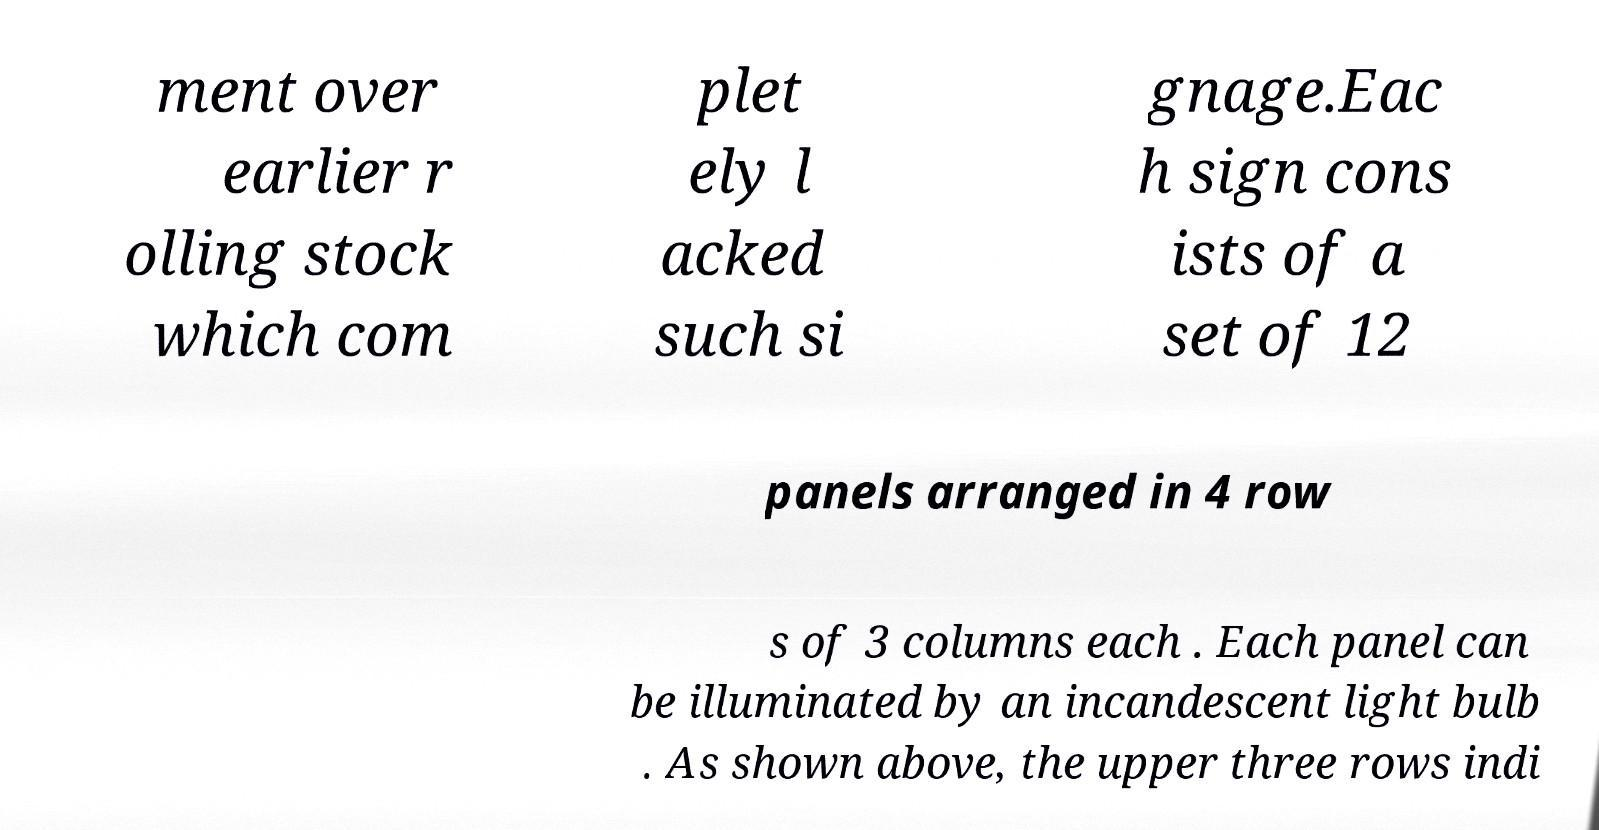Can you infer what the missing text might be discussing based on the visible content? Based on the visible content, which mentions signage, panels, and lighting, it's plausible that the missing text could further describe the signage's function, how it conveys information, or perhaps the material used for the sign's construction or design. 